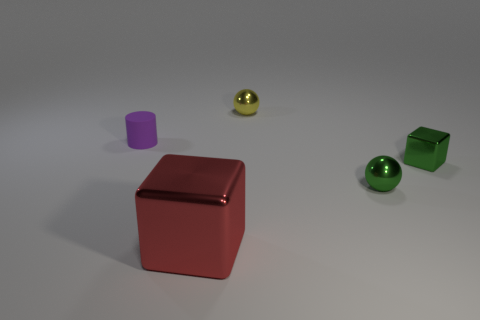Can you describe the sizes and colors of the objects in the image? Certainly! There are five distinct objects in varied sizes and colors. From left to right: a small purple cylinder, a larger red cube, a medium-sized yellow sphere, a small green cube, and a small green sphere. 